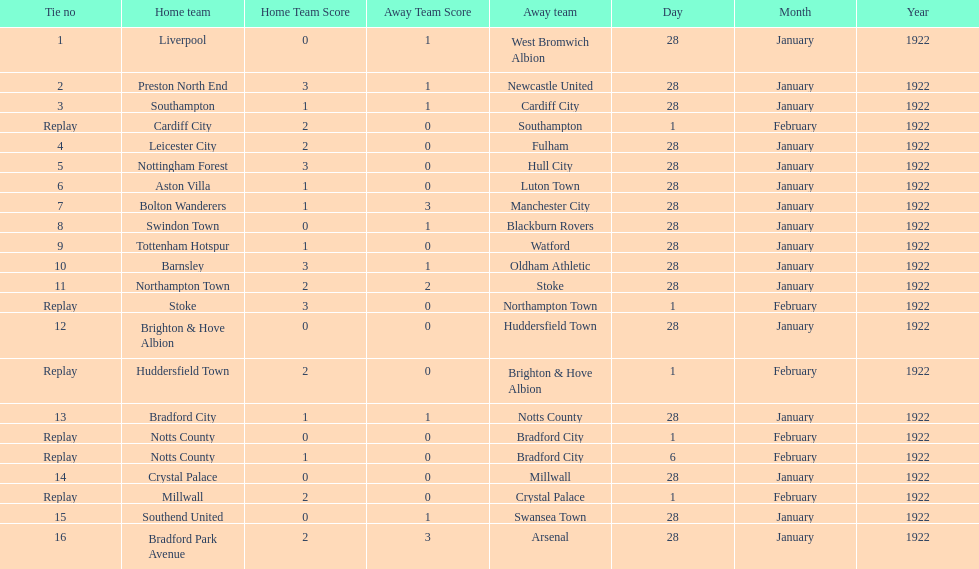What is the number of points scored on 6 february 1922? 1. I'm looking to parse the entire table for insights. Could you assist me with that? {'header': ['Tie no', 'Home team', 'Home Team Score', 'Away Team Score', 'Away team', 'Day', 'Month', 'Year'], 'rows': [['1', 'Liverpool', '0', '1', 'West Bromwich Albion', '28', 'January', '1922'], ['2', 'Preston North End', '3', '1', 'Newcastle United', '28', 'January', '1922'], ['3', 'Southampton', '1', '1', 'Cardiff City', '28', 'January', '1922'], ['Replay', 'Cardiff City', '2', '0', 'Southampton', '1', 'February', '1922'], ['4', 'Leicester City', '2', '0', 'Fulham', '28', 'January', '1922'], ['5', 'Nottingham Forest', '3', '0', 'Hull City', '28', 'January', '1922'], ['6', 'Aston Villa', '1', '0', 'Luton Town', '28', 'January', '1922'], ['7', 'Bolton Wanderers', '1', '3', 'Manchester City', '28', 'January', '1922'], ['8', 'Swindon Town', '0', '1', 'Blackburn Rovers', '28', 'January', '1922'], ['9', 'Tottenham Hotspur', '1', '0', 'Watford', '28', 'January', '1922'], ['10', 'Barnsley', '3', '1', 'Oldham Athletic', '28', 'January', '1922'], ['11', 'Northampton Town', '2', '2', 'Stoke', '28', 'January', '1922'], ['Replay', 'Stoke', '3', '0', 'Northampton Town', '1', 'February', '1922'], ['12', 'Brighton & Hove Albion', '0', '0', 'Huddersfield Town', '28', 'January', '1922'], ['Replay', 'Huddersfield Town', '2', '0', 'Brighton & Hove Albion', '1', 'February', '1922'], ['13', 'Bradford City', '1', '1', 'Notts County', '28', 'January', '1922'], ['Replay', 'Notts County', '0', '0', 'Bradford City', '1', 'February', '1922'], ['Replay', 'Notts County', '1', '0', 'Bradford City', '6', 'February', '1922'], ['14', 'Crystal Palace', '0', '0', 'Millwall', '28', 'January', '1922'], ['Replay', 'Millwall', '2', '0', 'Crystal Palace', '1', 'February', '1922'], ['15', 'Southend United', '0', '1', 'Swansea Town', '28', 'January', '1922'], ['16', 'Bradford Park Avenue', '2', '3', 'Arsenal', '28', 'January', '1922']]} 